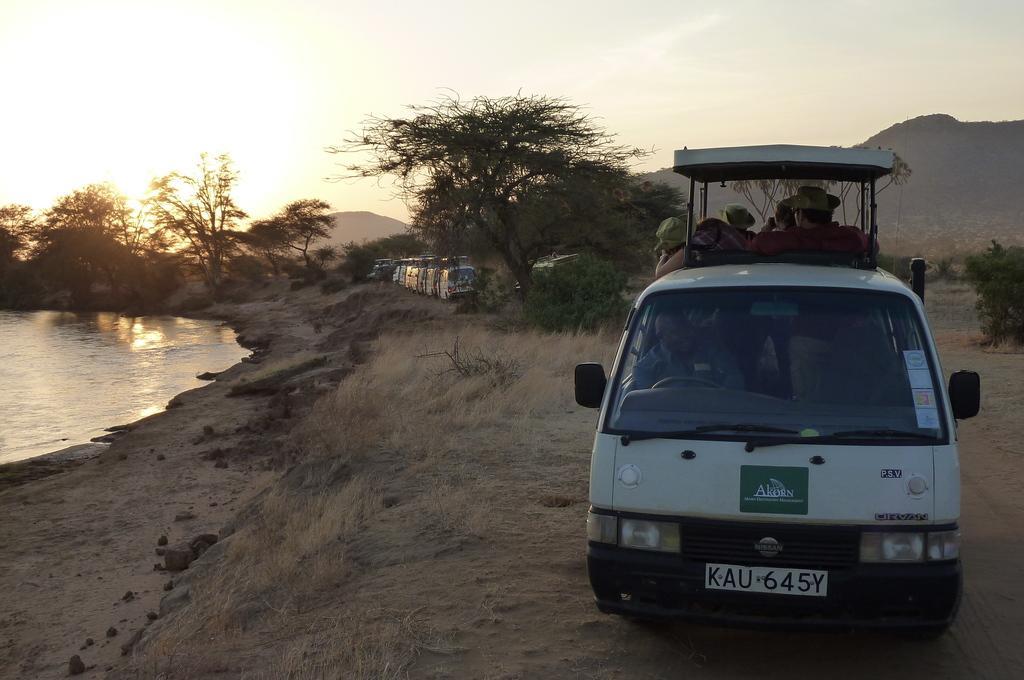Describe this image in one or two sentences. On the right side, we see the people riding a white vehicle. At the bottom, we see the soil road, stones and dry grass. Behind the vehicle, we see the trees and the vehicles in white color. On the left side, we see water and this water might be in the pond. There are trees and the hills in the background. At the top, we see the sky and the sun. 